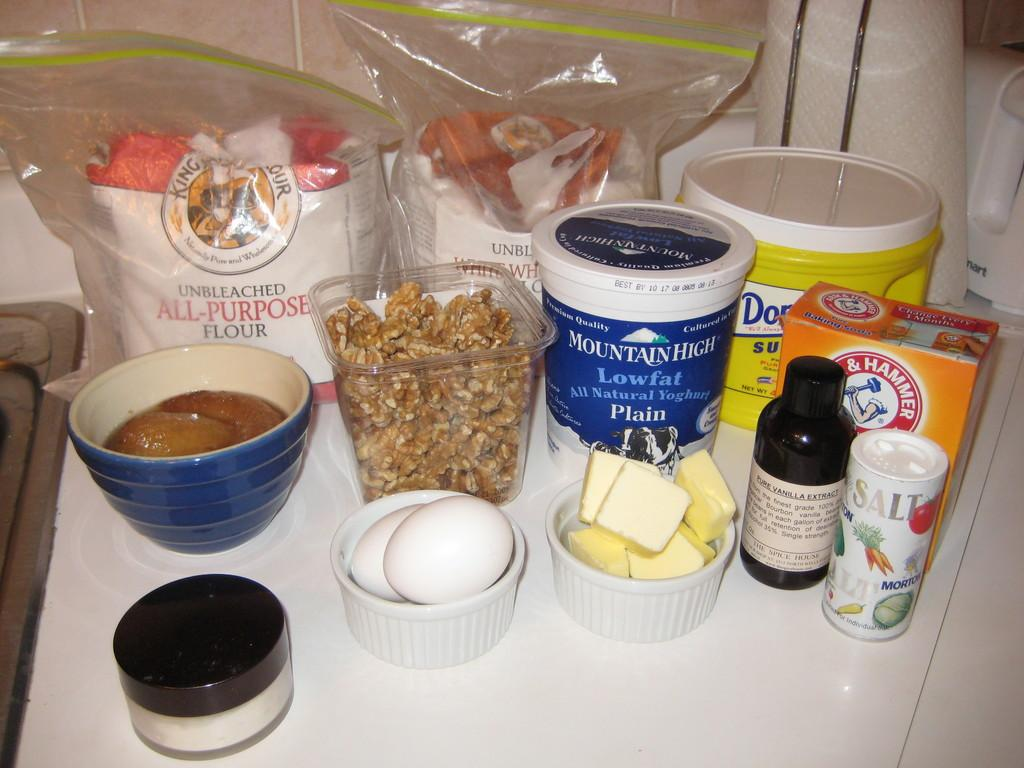<image>
Write a terse but informative summary of the picture. Blue bottle which says "Mountain High" next to some other ingredients. 